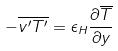Convert formula to latex. <formula><loc_0><loc_0><loc_500><loc_500>- \overline { v ^ { \prime } T ^ { \prime } } = \epsilon _ { H } \frac { \partial \overline { T } } { \partial y }</formula> 